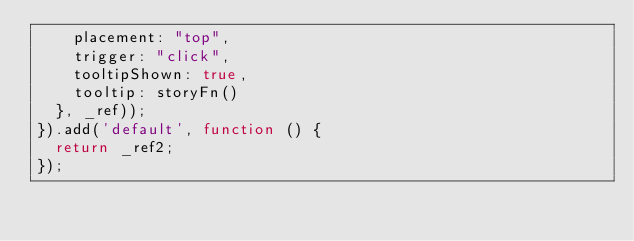Convert code to text. <code><loc_0><loc_0><loc_500><loc_500><_JavaScript_>    placement: "top",
    trigger: "click",
    tooltipShown: true,
    tooltip: storyFn()
  }, _ref));
}).add('default', function () {
  return _ref2;
});</code> 